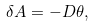<formula> <loc_0><loc_0><loc_500><loc_500>\delta A = - D \theta ,</formula> 